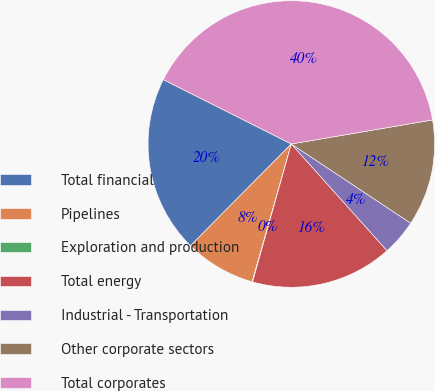Convert chart. <chart><loc_0><loc_0><loc_500><loc_500><pie_chart><fcel>Total financial<fcel>Pipelines<fcel>Exploration and production<fcel>Total energy<fcel>Industrial - Transportation<fcel>Other corporate sectors<fcel>Total corporates<nl><fcel>19.98%<fcel>8.02%<fcel>0.06%<fcel>15.99%<fcel>4.04%<fcel>12.01%<fcel>39.9%<nl></chart> 